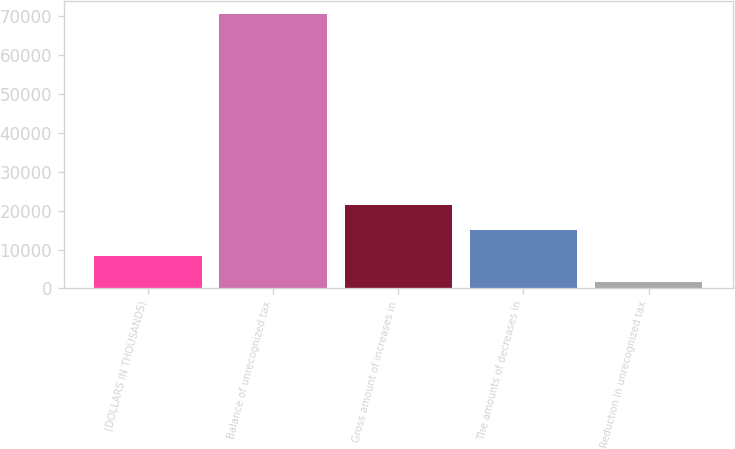<chart> <loc_0><loc_0><loc_500><loc_500><bar_chart><fcel>(DOLLARS IN THOUSANDS)<fcel>Balance of unrecognized tax<fcel>Gross amount of increases in<fcel>The amounts of decreases in<fcel>Reduction in unrecognized tax<nl><fcel>8310.4<fcel>70517.4<fcel>21489.2<fcel>14899.8<fcel>1721<nl></chart> 